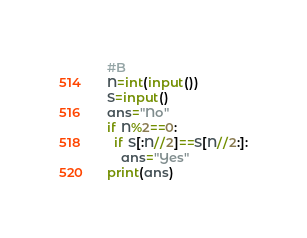<code> <loc_0><loc_0><loc_500><loc_500><_Python_>#B
N=int(input())
S=input()
ans="No"
if N%2==0:
  if S[:N//2]==S[N//2:]:
    ans="Yes"
print(ans)</code> 